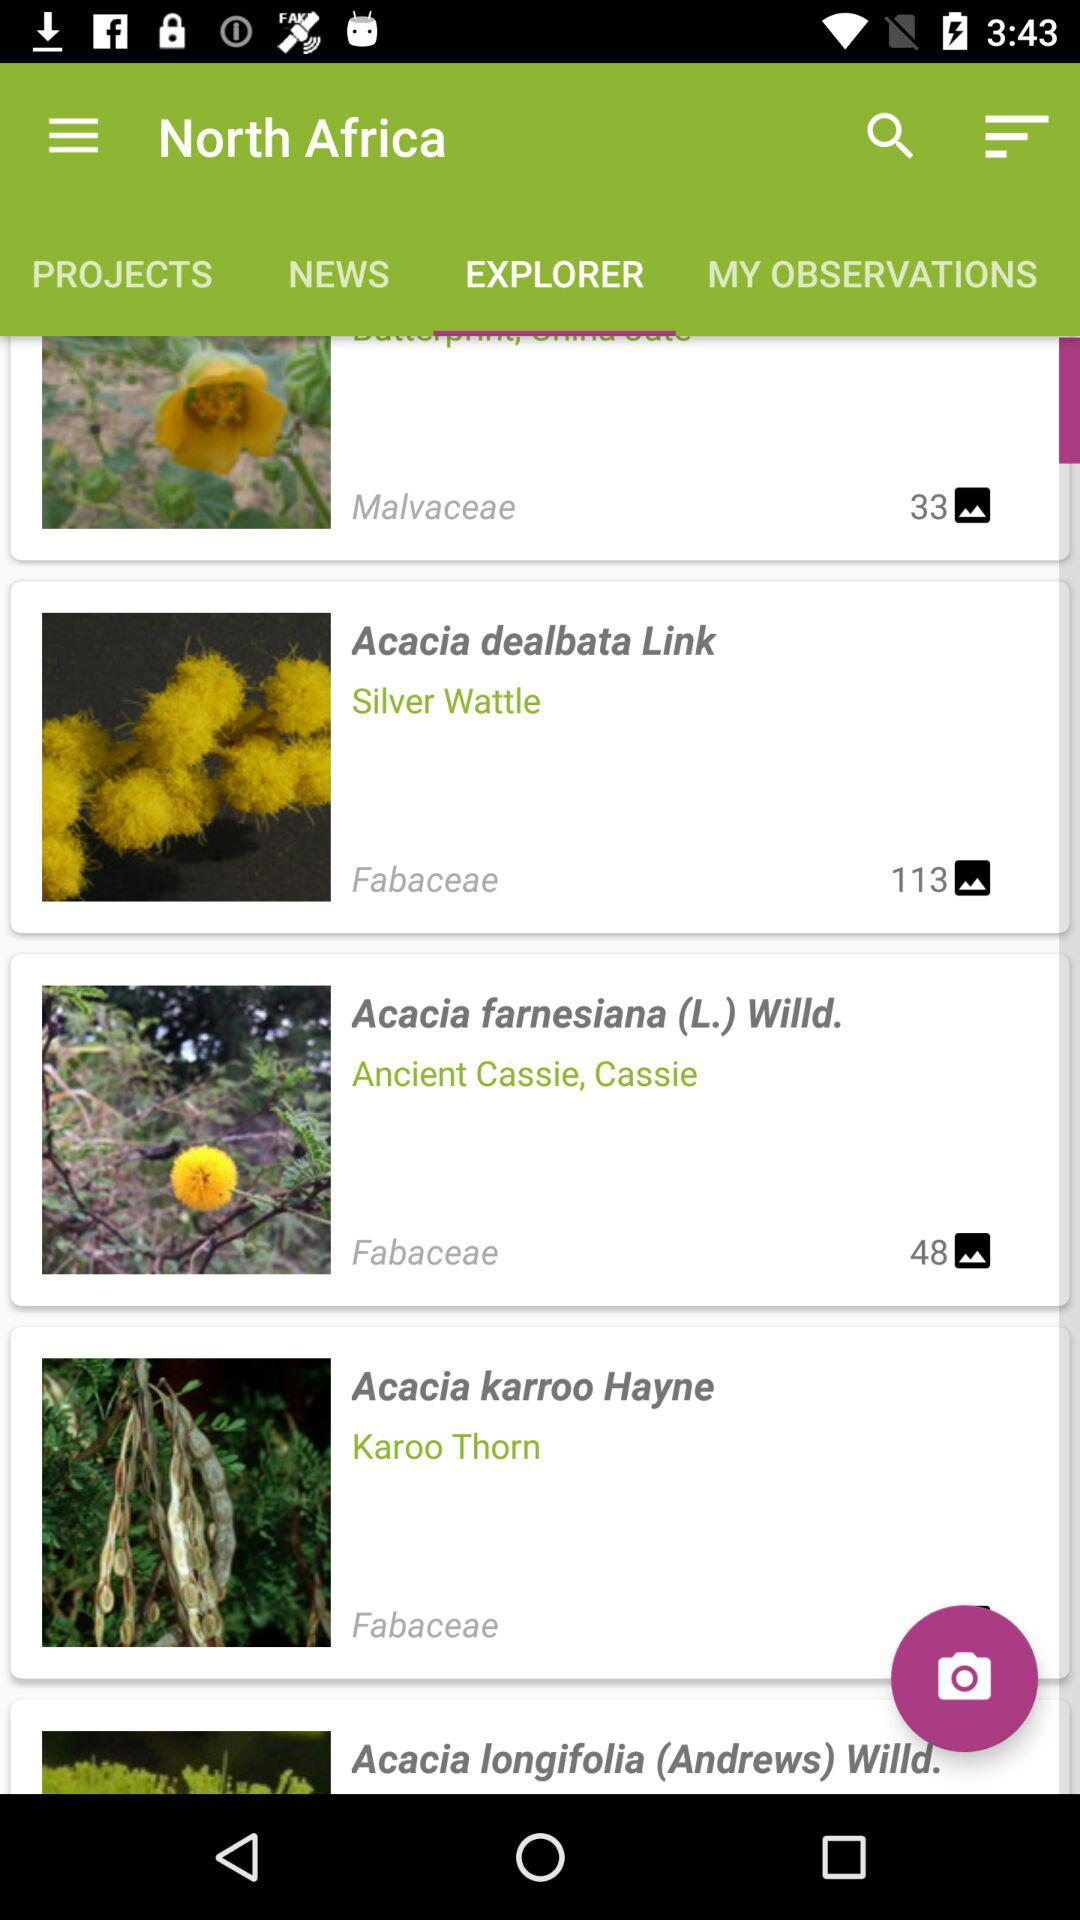Can you tell me more about the NEWS tab? The 'NEWS' tab, located next to the 'PROJECTS' tab on the app's interface, probably offers the latest updates, articles, or news related to the botanical communities or environmental science. This could include information on new species discoveries, conservation efforts, or botanical research findings relevant to the regions or species featured in the app. 